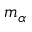<formula> <loc_0><loc_0><loc_500><loc_500>m _ { \alpha }</formula> 